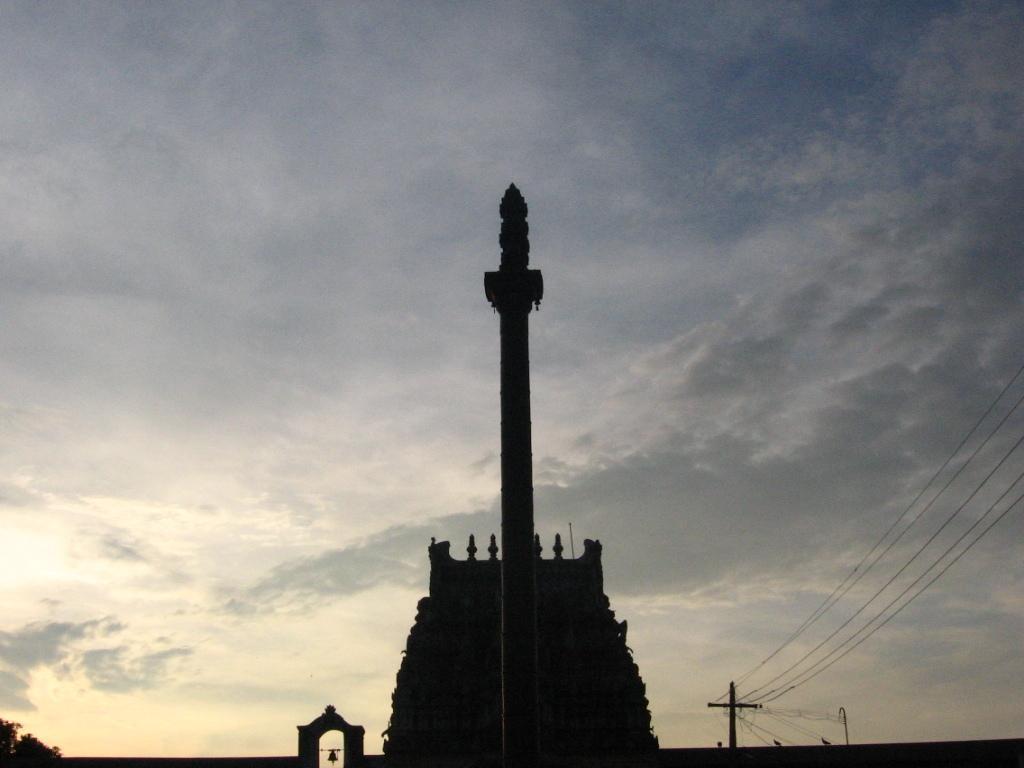In one or two sentences, can you explain what this image depicts? In this picture I can see there is a temple, a pole, there is a wall, there is a tree at the left side, there is an electric pole on right side and there are a few birds on the wall at the right side. The sky is clear. 